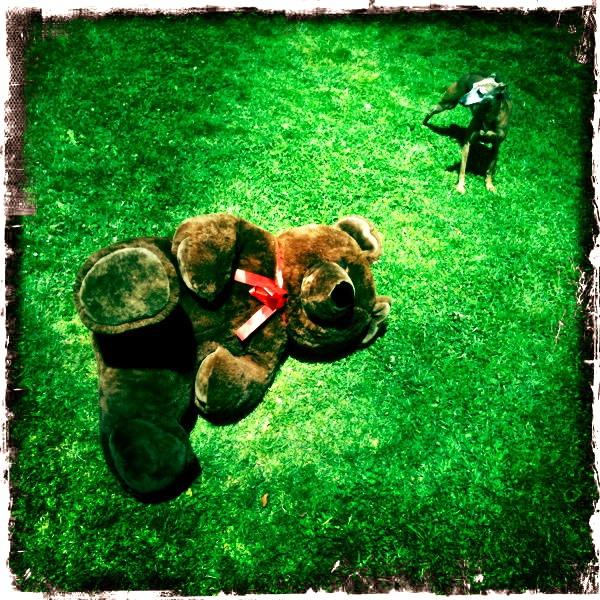Is there a photo effect on the image?
Keep it brief. Yes. Where was picture made?
Answer briefly. Backyard. What animal is shown?
Answer briefly. Dog. 